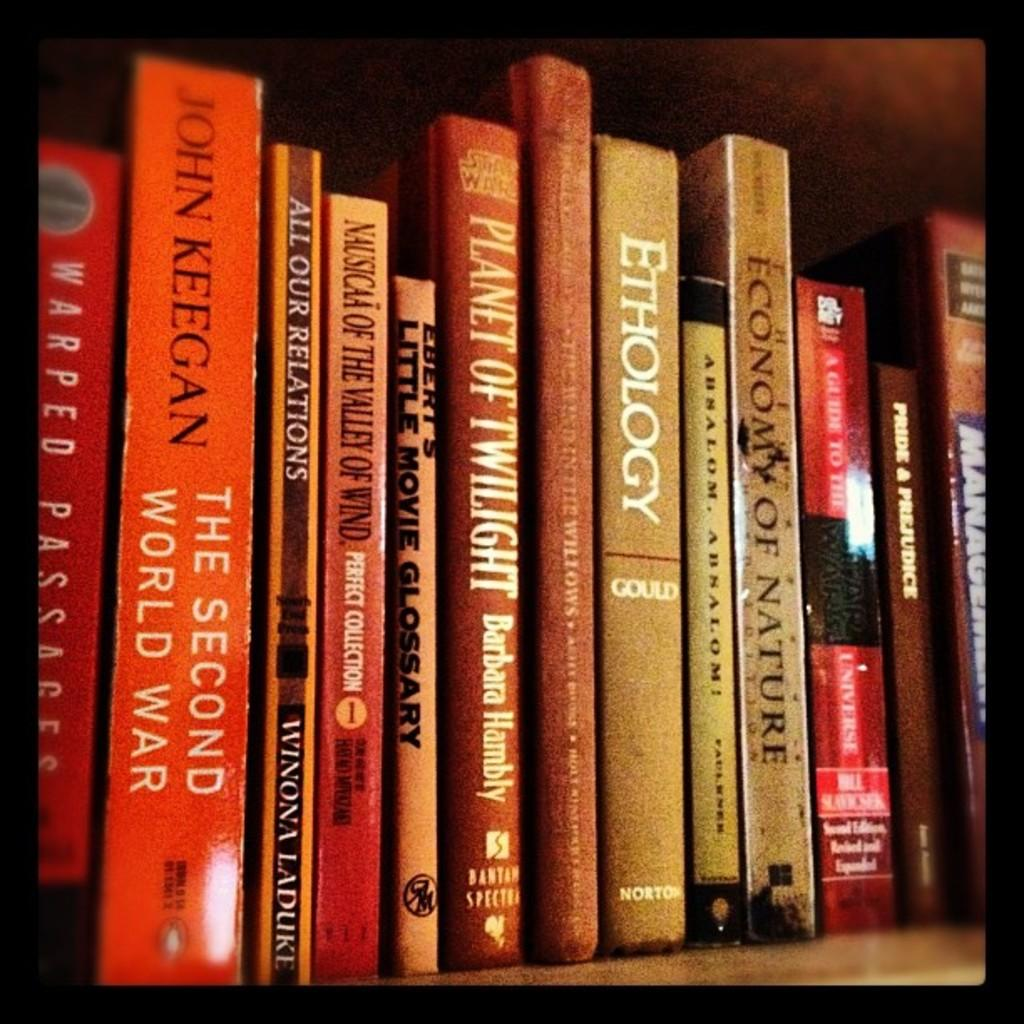Provide a one-sentence caption for the provided image. A collection of books with everything from The Second World War to Ethology by Gould. 